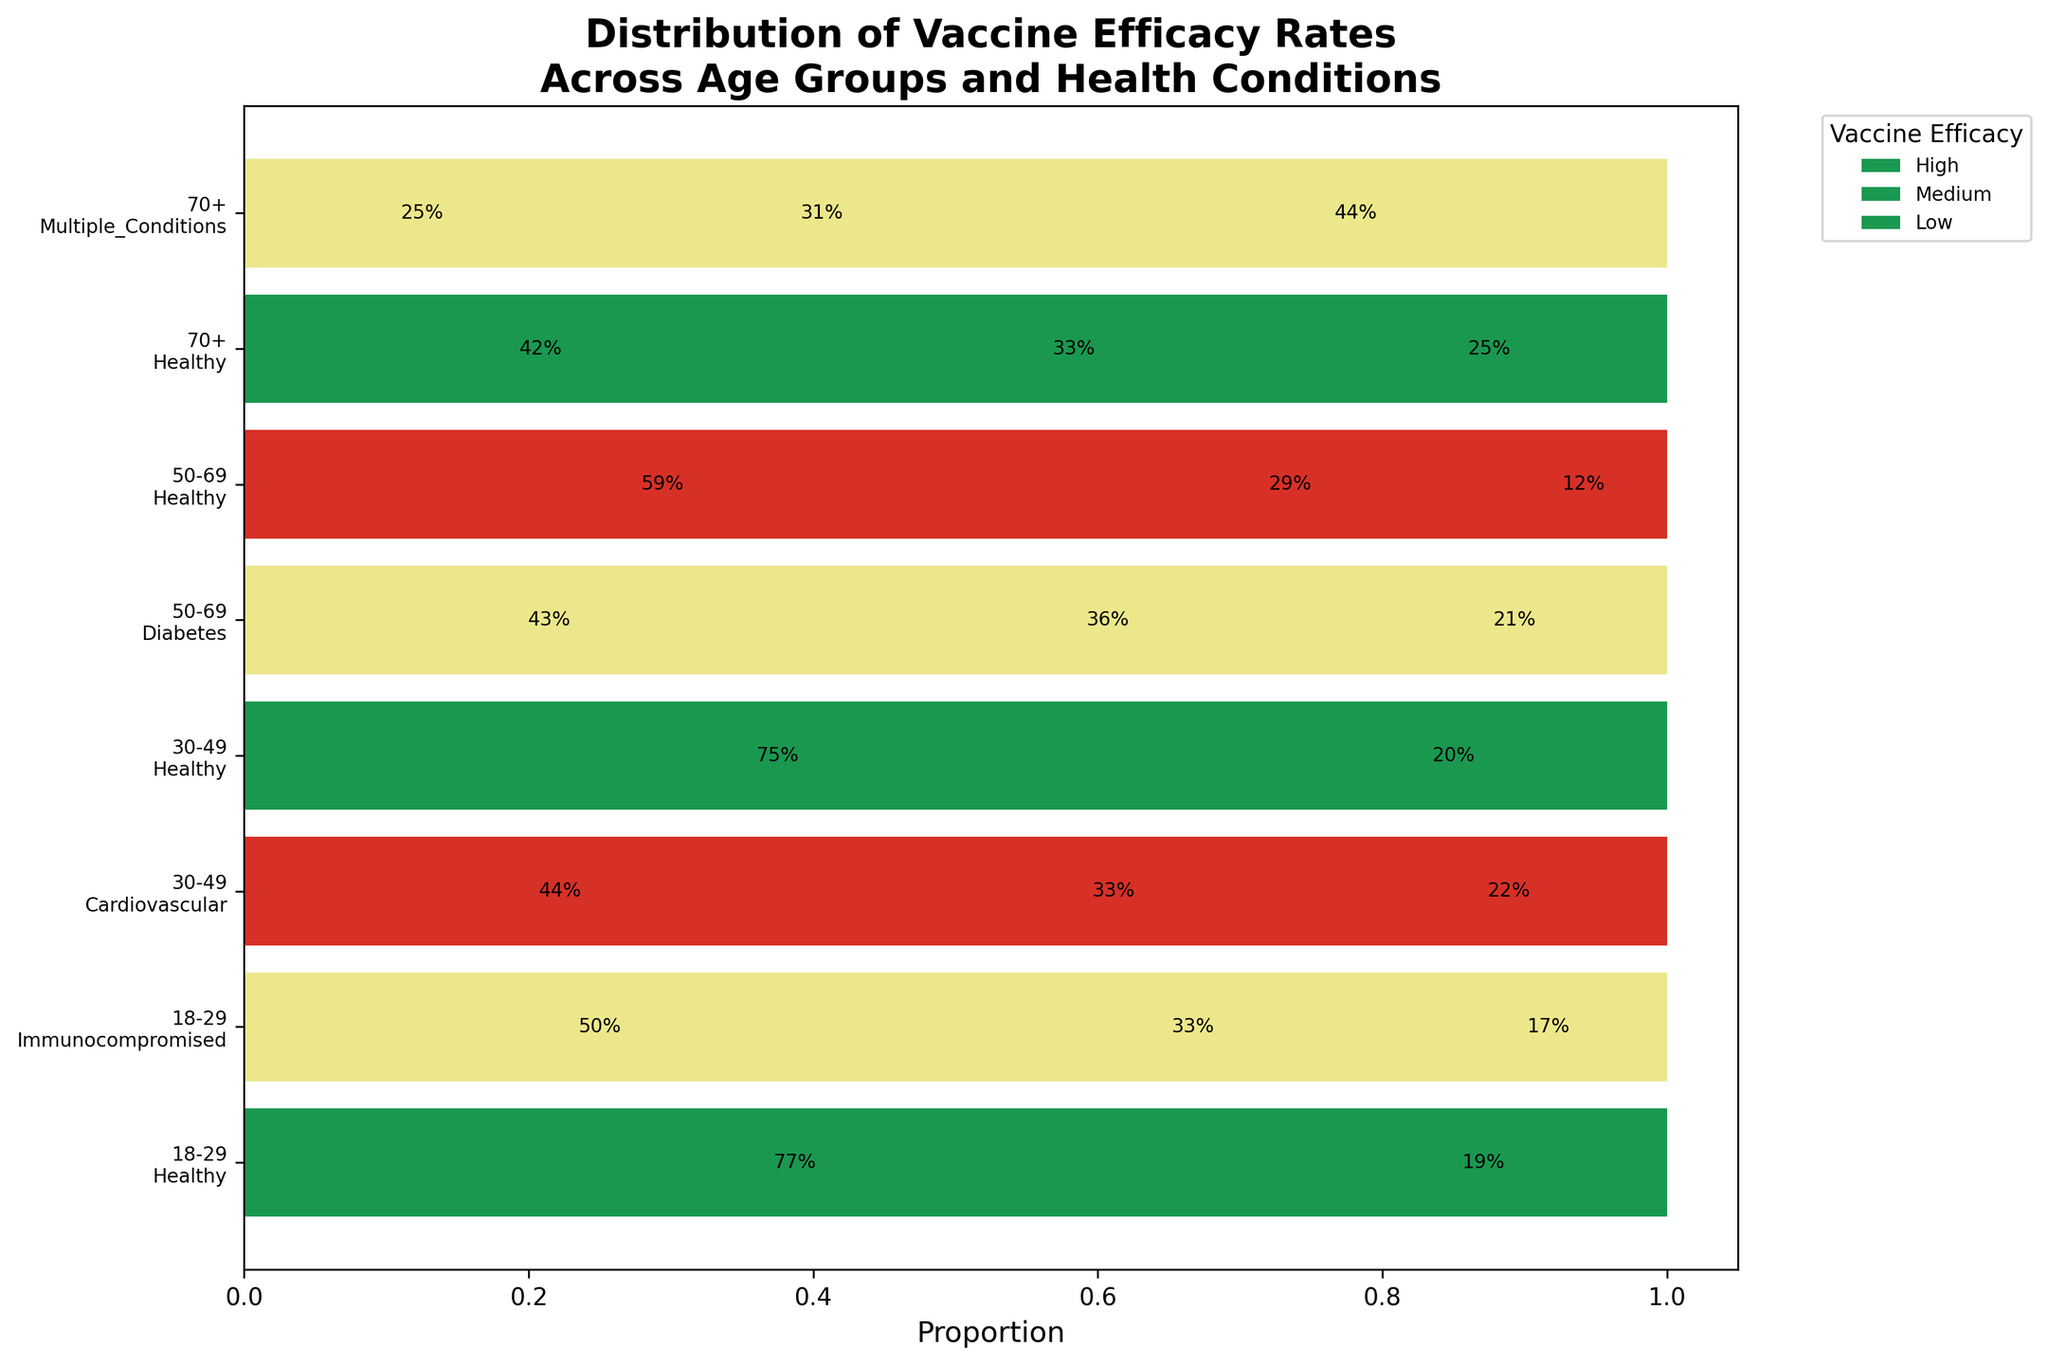What is the title of the mosaic plot? The title is located at the top of the plot, and it summarizes what is being depicted in the plot.
Answer: Distribution of Vaccine Efficacy Rates Across Age Groups and Health Conditions Which health condition in the age group 50-69 has the highest proportion of 'High' vaccine efficacy? Look for the age group 50-69 and compare the segments marked as 'High' for each health condition.
Answer: Healthy What is the proportion of 'Low' vaccine efficacy in the 70+ age group with Multiple Conditions? Find the 70+ age group with Multiple Conditions and check the length of the 'Low' segment in the horizontal bar to estimate the proportion.
Answer: ~44% Compare the proportion of 'High' efficacy between the 18-29 and 30-49 age groups for Healthy individuals. Which is higher? Identify the Healthy individuals in both age groups and compare the length of the 'High' efficacy segments to see which is longer.
Answer: 30-49 What is the cumulative proportion of 'Medium' and 'Low' vaccine efficacy for Immunocompromised individuals in the 18-29 age group? Find the 'Medium' and 'Low' segments for Immunocompromised individuals in the 18-29 age group and sum their proportions.
Answer: ~50% In the age group 70+, which health condition has the smallest proportion of 'High' vaccine efficacy? Look at the 'High' efficacy segments for the 70+ age group and determine which health condition has the smallest slice.
Answer: Multiple Conditions Which age group shows a higher variability in vaccine efficacy among Healthy individuals? Compare the lengths of the segments for Healthy individuals across different age groups and observe the differences in proportions.
Answer: 70+ In the age group 18-29, which sector shows the smallest proportion for 'Medium' vaccine efficacy? Check all the sectors within the age group 18-29 and identify which one has the smallest proportion for the 'Medium' efficacy segment.
Answer: Healthy 